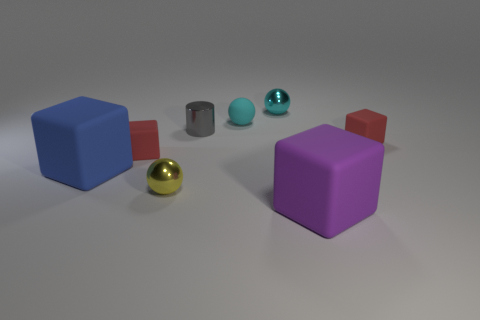What is the color of the sphere that is the same material as the large blue cube?
Give a very brief answer. Cyan. Is the yellow shiny ball the same size as the blue thing?
Keep it short and to the point. No. What material is the tiny yellow object?
Keep it short and to the point. Metal. There is a purple object that is the same size as the blue matte object; what material is it?
Keep it short and to the point. Rubber. Is there a green matte cube that has the same size as the gray metallic thing?
Provide a short and direct response. No. Is the number of big matte blocks that are behind the big purple matte cube the same as the number of small gray metallic things that are right of the gray metal cylinder?
Your answer should be very brief. No. Is the number of big green metallic cylinders greater than the number of big purple rubber cubes?
Give a very brief answer. No. How many rubber objects are either red cubes or cylinders?
Your response must be concise. 2. What number of large things are the same color as the matte ball?
Provide a short and direct response. 0. What is the big thing behind the large matte object that is on the right side of the big thing that is behind the big purple rubber cube made of?
Keep it short and to the point. Rubber. 